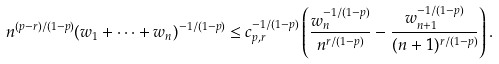<formula> <loc_0><loc_0><loc_500><loc_500>n ^ { ( p - r ) / ( 1 - p ) } ( w _ { 1 } + \cdots + w _ { n } ) ^ { - 1 / ( 1 - p ) } \leq c ^ { - 1 / ( 1 - p ) } _ { p , r } \left ( \frac { w ^ { - 1 / ( 1 - p ) } _ { n } } { n ^ { r / ( 1 - p ) } } - \frac { w ^ { - 1 / ( 1 - p ) } _ { n + 1 } } { ( n + 1 ) ^ { r / ( 1 - p ) } } \right ) .</formula> 